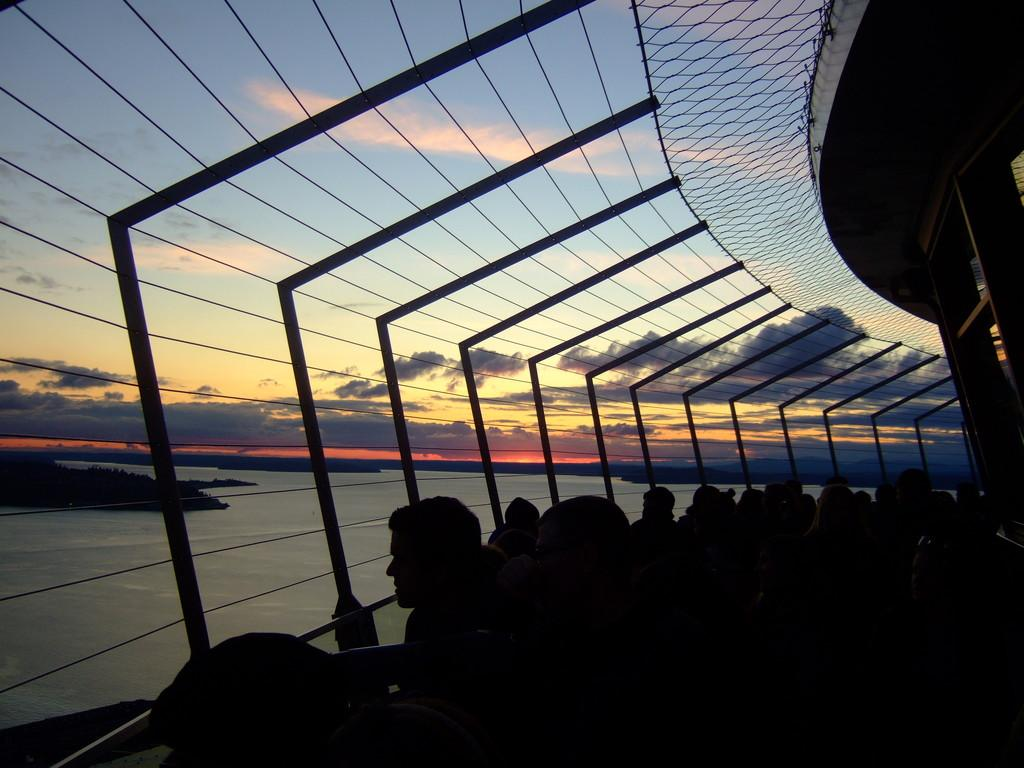What are the people in the image doing? The people in the image are standing near a fence. Where is the fence located? The fence is in a building. What type of natural elements can be seen in the image? There are trees and water visible in the image. What is the condition of the sky in the image? The sky has clouds in the image. What color is the sweater worn by the person in the image? There is no person wearing a sweater in the image. How does the wind affect the trees in the image? There is no wind present in the image, so its effect on the trees cannot be determined. 